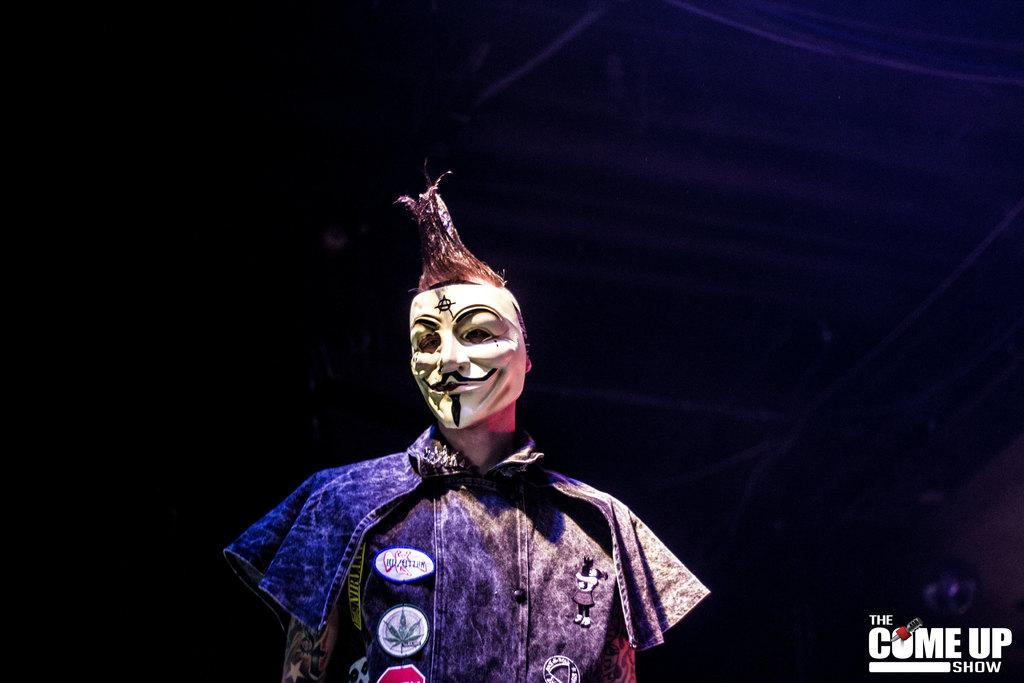What is the person in the image wearing on their face? The person in the image is wearing a mask. What can be seen on the right side of the image? There is an object on the right side of the image. What is written or displayed at the bottom of the image? There is text at the bottom of the image. How does the person in the image use magic to create a loaf of bread? There is no mention of magic or a loaf of bread in the image; the person is simply wearing a mask. 